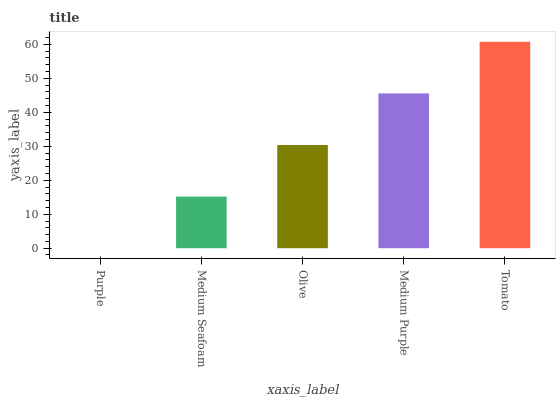Is Purple the minimum?
Answer yes or no. Yes. Is Tomato the maximum?
Answer yes or no. Yes. Is Medium Seafoam the minimum?
Answer yes or no. No. Is Medium Seafoam the maximum?
Answer yes or no. No. Is Medium Seafoam greater than Purple?
Answer yes or no. Yes. Is Purple less than Medium Seafoam?
Answer yes or no. Yes. Is Purple greater than Medium Seafoam?
Answer yes or no. No. Is Medium Seafoam less than Purple?
Answer yes or no. No. Is Olive the high median?
Answer yes or no. Yes. Is Olive the low median?
Answer yes or no. Yes. Is Medium Purple the high median?
Answer yes or no. No. Is Purple the low median?
Answer yes or no. No. 